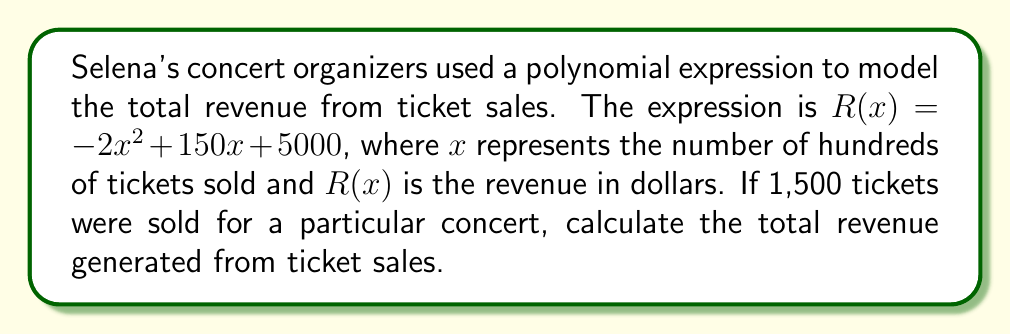Can you answer this question? To solve this problem, we need to follow these steps:

1) First, we need to determine the value of $x$. We're told that 1,500 tickets were sold. Since $x$ represents hundreds of tickets, we divide 1,500 by 100:

   $x = 1500 \div 100 = 15$

2) Now that we know $x = 15$, we can substitute this value into the revenue function $R(x)$:

   $R(15) = -2(15)^2 + 150(15) + 5000$

3) Let's evaluate this expression step by step:

   $R(15) = -2(225) + 150(15) + 5000$
   
   $R(15) = -450 + 2250 + 5000$

4) Now we can simply add these numbers:

   $R(15) = 6800$

Therefore, the total revenue generated from selling 1,500 tickets is $6,800.
Answer: $6,800 